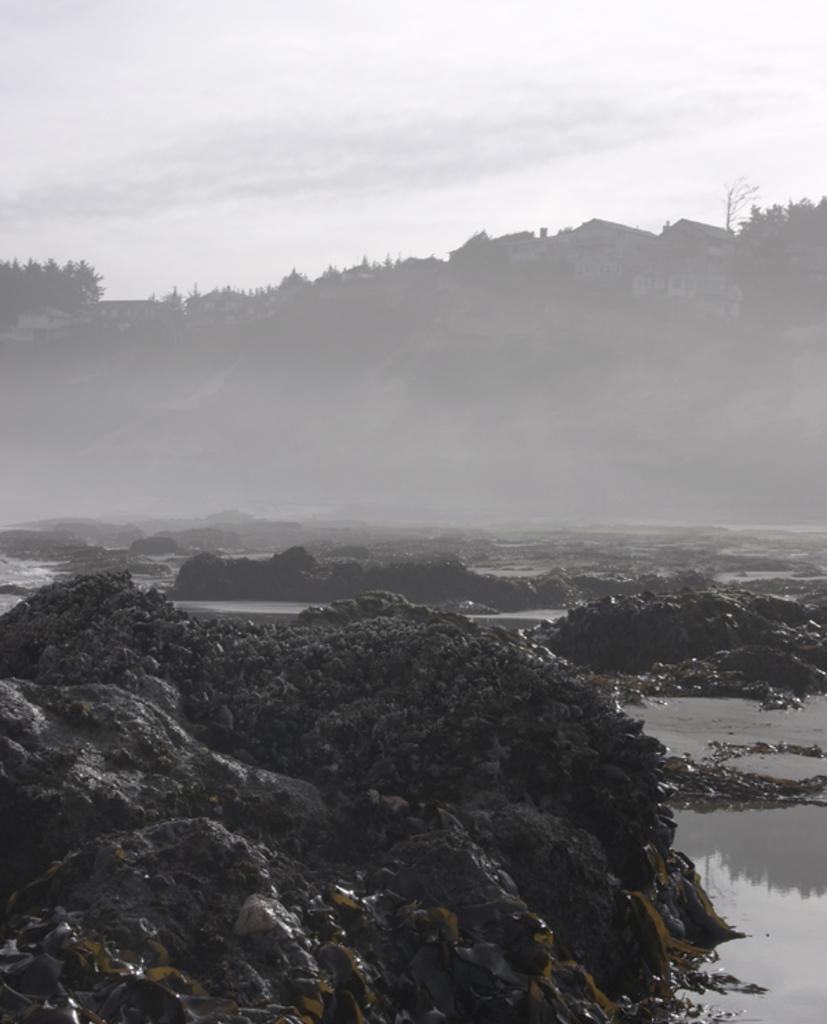What type of natural landscape can be seen in the image? There are mountains in the image. What else can be seen in the image besides the mountains? There is water, trees, and the sky visible in the image. How would you describe the sky in the image? The sky appears cloudy in the image. How many ants can be seen crawling on the actor's waste in the image? There is no actor or waste present in the image, and therefore no ants can be observed. 